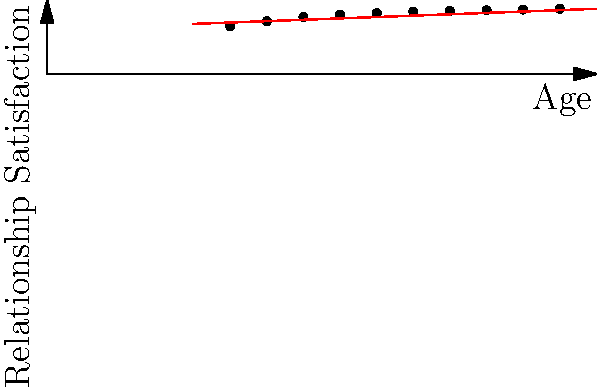Based on the scatter plot showing the correlation between relationship satisfaction and age, what type of relationship is observed, and what does this suggest about relationship satisfaction as people age? To answer this question, we need to analyze the scatter plot and the trend it represents:

1. Observe the overall pattern: The points on the scatter plot show an upward trend from left to right.

2. Identify the variables:
   - X-axis: Age (ranging from 25 to 70 years)
   - Y-axis: Relationship Satisfaction (scale from 0 to 10)

3. Analyze the trend:
   - As age increases, relationship satisfaction generally increases.
   - The increase appears to be steady and consistent.

4. Interpret the relationship:
   - This pattern indicates a positive correlation between age and relationship satisfaction.
   - The relationship appears to be approximately linear, as shown by the red best-fit line.

5. Consider the strength of the relationship:
   - The points are relatively close to the best-fit line, suggesting a moderately strong correlation.

6. Interpret the findings:
   - The positive correlation suggests that, on average, relationship satisfaction tends to improve as people get older.
   - This could be due to factors such as increased emotional maturity, better communication skills, or more realistic expectations in relationships that come with age and experience.

7. Limitations to consider:
   - This is an average trend and may not apply to all individuals or couples.
   - Other factors not shown in this plot could also influence relationship satisfaction.
Answer: Positive correlation; relationship satisfaction tends to increase with age. 